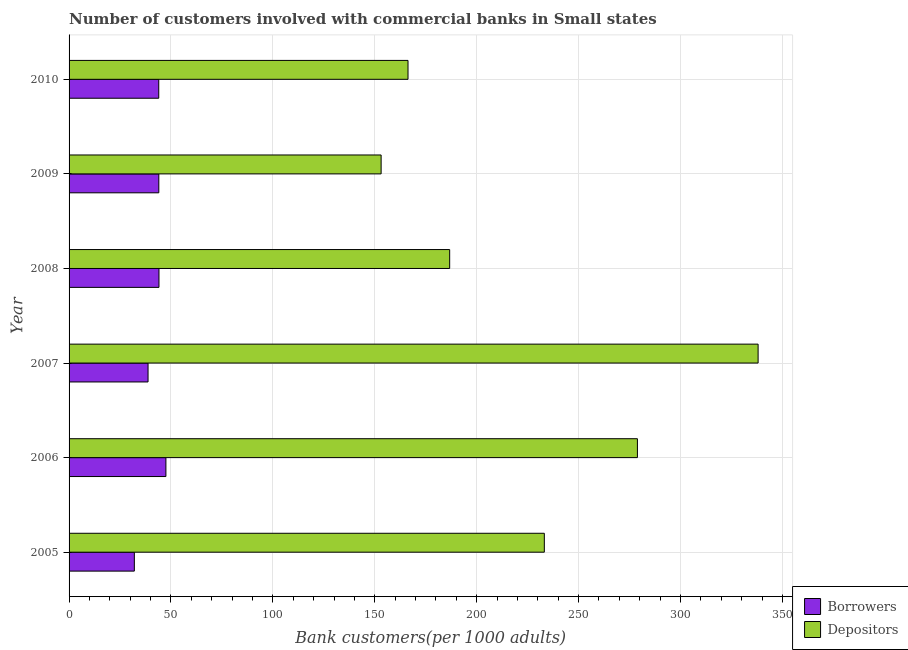How many different coloured bars are there?
Keep it short and to the point. 2. How many groups of bars are there?
Offer a very short reply. 6. How many bars are there on the 4th tick from the bottom?
Provide a succinct answer. 2. What is the number of borrowers in 2005?
Provide a succinct answer. 32.03. Across all years, what is the maximum number of depositors?
Offer a very short reply. 338.08. Across all years, what is the minimum number of depositors?
Make the answer very short. 153.11. In which year was the number of borrowers maximum?
Offer a very short reply. 2006. What is the total number of borrowers in the graph?
Your answer should be compact. 250.43. What is the difference between the number of borrowers in 2008 and that in 2009?
Give a very brief answer. 0.07. What is the difference between the number of depositors in 2005 and the number of borrowers in 2007?
Ensure brevity in your answer.  194.43. What is the average number of depositors per year?
Provide a succinct answer. 226.05. In the year 2005, what is the difference between the number of borrowers and number of depositors?
Your answer should be compact. -201.16. In how many years, is the number of depositors greater than 20 ?
Make the answer very short. 6. What is the ratio of the number of borrowers in 2006 to that in 2008?
Offer a terse response. 1.08. Is the number of depositors in 2006 less than that in 2009?
Make the answer very short. No. What is the difference between the highest and the second highest number of depositors?
Offer a terse response. 59.21. What is the difference between the highest and the lowest number of borrowers?
Offer a very short reply. 15.48. What does the 2nd bar from the top in 2007 represents?
Provide a succinct answer. Borrowers. What does the 2nd bar from the bottom in 2007 represents?
Give a very brief answer. Depositors. How many bars are there?
Give a very brief answer. 12. Are all the bars in the graph horizontal?
Your answer should be very brief. Yes. How many years are there in the graph?
Your response must be concise. 6. What is the difference between two consecutive major ticks on the X-axis?
Your answer should be compact. 50. Does the graph contain any zero values?
Ensure brevity in your answer.  No. Does the graph contain grids?
Your response must be concise. Yes. Where does the legend appear in the graph?
Provide a succinct answer. Bottom right. What is the title of the graph?
Offer a terse response. Number of customers involved with commercial banks in Small states. Does "Under five" appear as one of the legend labels in the graph?
Your answer should be compact. No. What is the label or title of the X-axis?
Provide a short and direct response. Bank customers(per 1000 adults). What is the label or title of the Y-axis?
Offer a very short reply. Year. What is the Bank customers(per 1000 adults) in Borrowers in 2005?
Your response must be concise. 32.03. What is the Bank customers(per 1000 adults) in Depositors in 2005?
Give a very brief answer. 233.18. What is the Bank customers(per 1000 adults) in Borrowers in 2006?
Offer a terse response. 47.51. What is the Bank customers(per 1000 adults) in Depositors in 2006?
Ensure brevity in your answer.  278.86. What is the Bank customers(per 1000 adults) in Borrowers in 2007?
Give a very brief answer. 38.75. What is the Bank customers(per 1000 adults) of Depositors in 2007?
Offer a very short reply. 338.08. What is the Bank customers(per 1000 adults) of Borrowers in 2008?
Keep it short and to the point. 44.11. What is the Bank customers(per 1000 adults) in Depositors in 2008?
Your response must be concise. 186.74. What is the Bank customers(per 1000 adults) of Borrowers in 2009?
Provide a succinct answer. 44.03. What is the Bank customers(per 1000 adults) of Depositors in 2009?
Your answer should be very brief. 153.11. What is the Bank customers(per 1000 adults) in Borrowers in 2010?
Provide a succinct answer. 44. What is the Bank customers(per 1000 adults) of Depositors in 2010?
Your answer should be compact. 166.31. Across all years, what is the maximum Bank customers(per 1000 adults) in Borrowers?
Keep it short and to the point. 47.51. Across all years, what is the maximum Bank customers(per 1000 adults) of Depositors?
Keep it short and to the point. 338.08. Across all years, what is the minimum Bank customers(per 1000 adults) of Borrowers?
Your response must be concise. 32.03. Across all years, what is the minimum Bank customers(per 1000 adults) in Depositors?
Keep it short and to the point. 153.11. What is the total Bank customers(per 1000 adults) in Borrowers in the graph?
Provide a succinct answer. 250.43. What is the total Bank customers(per 1000 adults) of Depositors in the graph?
Provide a succinct answer. 1356.28. What is the difference between the Bank customers(per 1000 adults) of Borrowers in 2005 and that in 2006?
Your answer should be very brief. -15.48. What is the difference between the Bank customers(per 1000 adults) of Depositors in 2005 and that in 2006?
Offer a terse response. -45.68. What is the difference between the Bank customers(per 1000 adults) of Borrowers in 2005 and that in 2007?
Your answer should be compact. -6.72. What is the difference between the Bank customers(per 1000 adults) in Depositors in 2005 and that in 2007?
Your response must be concise. -104.89. What is the difference between the Bank customers(per 1000 adults) in Borrowers in 2005 and that in 2008?
Ensure brevity in your answer.  -12.08. What is the difference between the Bank customers(per 1000 adults) in Depositors in 2005 and that in 2008?
Make the answer very short. 46.44. What is the difference between the Bank customers(per 1000 adults) of Borrowers in 2005 and that in 2009?
Offer a very short reply. -12. What is the difference between the Bank customers(per 1000 adults) of Depositors in 2005 and that in 2009?
Your answer should be compact. 80.08. What is the difference between the Bank customers(per 1000 adults) in Borrowers in 2005 and that in 2010?
Make the answer very short. -11.98. What is the difference between the Bank customers(per 1000 adults) of Depositors in 2005 and that in 2010?
Provide a succinct answer. 66.88. What is the difference between the Bank customers(per 1000 adults) of Borrowers in 2006 and that in 2007?
Provide a short and direct response. 8.76. What is the difference between the Bank customers(per 1000 adults) of Depositors in 2006 and that in 2007?
Your response must be concise. -59.21. What is the difference between the Bank customers(per 1000 adults) in Borrowers in 2006 and that in 2008?
Your answer should be compact. 3.4. What is the difference between the Bank customers(per 1000 adults) of Depositors in 2006 and that in 2008?
Provide a succinct answer. 92.12. What is the difference between the Bank customers(per 1000 adults) in Borrowers in 2006 and that in 2009?
Provide a succinct answer. 3.48. What is the difference between the Bank customers(per 1000 adults) of Depositors in 2006 and that in 2009?
Provide a short and direct response. 125.76. What is the difference between the Bank customers(per 1000 adults) of Borrowers in 2006 and that in 2010?
Your answer should be compact. 3.5. What is the difference between the Bank customers(per 1000 adults) in Depositors in 2006 and that in 2010?
Your answer should be compact. 112.56. What is the difference between the Bank customers(per 1000 adults) in Borrowers in 2007 and that in 2008?
Give a very brief answer. -5.36. What is the difference between the Bank customers(per 1000 adults) of Depositors in 2007 and that in 2008?
Your answer should be compact. 151.33. What is the difference between the Bank customers(per 1000 adults) of Borrowers in 2007 and that in 2009?
Your answer should be compact. -5.28. What is the difference between the Bank customers(per 1000 adults) of Depositors in 2007 and that in 2009?
Provide a short and direct response. 184.97. What is the difference between the Bank customers(per 1000 adults) in Borrowers in 2007 and that in 2010?
Your response must be concise. -5.25. What is the difference between the Bank customers(per 1000 adults) of Depositors in 2007 and that in 2010?
Give a very brief answer. 171.77. What is the difference between the Bank customers(per 1000 adults) in Borrowers in 2008 and that in 2009?
Provide a short and direct response. 0.08. What is the difference between the Bank customers(per 1000 adults) of Depositors in 2008 and that in 2009?
Offer a very short reply. 33.63. What is the difference between the Bank customers(per 1000 adults) in Borrowers in 2008 and that in 2010?
Give a very brief answer. 0.1. What is the difference between the Bank customers(per 1000 adults) in Depositors in 2008 and that in 2010?
Your response must be concise. 20.43. What is the difference between the Bank customers(per 1000 adults) in Borrowers in 2009 and that in 2010?
Your answer should be very brief. 0.03. What is the difference between the Bank customers(per 1000 adults) in Depositors in 2009 and that in 2010?
Make the answer very short. -13.2. What is the difference between the Bank customers(per 1000 adults) in Borrowers in 2005 and the Bank customers(per 1000 adults) in Depositors in 2006?
Offer a very short reply. -246.84. What is the difference between the Bank customers(per 1000 adults) in Borrowers in 2005 and the Bank customers(per 1000 adults) in Depositors in 2007?
Your response must be concise. -306.05. What is the difference between the Bank customers(per 1000 adults) in Borrowers in 2005 and the Bank customers(per 1000 adults) in Depositors in 2008?
Your response must be concise. -154.71. What is the difference between the Bank customers(per 1000 adults) in Borrowers in 2005 and the Bank customers(per 1000 adults) in Depositors in 2009?
Provide a short and direct response. -121.08. What is the difference between the Bank customers(per 1000 adults) in Borrowers in 2005 and the Bank customers(per 1000 adults) in Depositors in 2010?
Your response must be concise. -134.28. What is the difference between the Bank customers(per 1000 adults) in Borrowers in 2006 and the Bank customers(per 1000 adults) in Depositors in 2007?
Keep it short and to the point. -290.57. What is the difference between the Bank customers(per 1000 adults) of Borrowers in 2006 and the Bank customers(per 1000 adults) of Depositors in 2008?
Make the answer very short. -139.23. What is the difference between the Bank customers(per 1000 adults) of Borrowers in 2006 and the Bank customers(per 1000 adults) of Depositors in 2009?
Your response must be concise. -105.6. What is the difference between the Bank customers(per 1000 adults) of Borrowers in 2006 and the Bank customers(per 1000 adults) of Depositors in 2010?
Make the answer very short. -118.8. What is the difference between the Bank customers(per 1000 adults) of Borrowers in 2007 and the Bank customers(per 1000 adults) of Depositors in 2008?
Offer a terse response. -147.99. What is the difference between the Bank customers(per 1000 adults) in Borrowers in 2007 and the Bank customers(per 1000 adults) in Depositors in 2009?
Provide a succinct answer. -114.36. What is the difference between the Bank customers(per 1000 adults) in Borrowers in 2007 and the Bank customers(per 1000 adults) in Depositors in 2010?
Your answer should be very brief. -127.56. What is the difference between the Bank customers(per 1000 adults) of Borrowers in 2008 and the Bank customers(per 1000 adults) of Depositors in 2009?
Keep it short and to the point. -109. What is the difference between the Bank customers(per 1000 adults) in Borrowers in 2008 and the Bank customers(per 1000 adults) in Depositors in 2010?
Keep it short and to the point. -122.2. What is the difference between the Bank customers(per 1000 adults) of Borrowers in 2009 and the Bank customers(per 1000 adults) of Depositors in 2010?
Make the answer very short. -122.28. What is the average Bank customers(per 1000 adults) of Borrowers per year?
Keep it short and to the point. 41.74. What is the average Bank customers(per 1000 adults) of Depositors per year?
Keep it short and to the point. 226.05. In the year 2005, what is the difference between the Bank customers(per 1000 adults) of Borrowers and Bank customers(per 1000 adults) of Depositors?
Keep it short and to the point. -201.15. In the year 2006, what is the difference between the Bank customers(per 1000 adults) in Borrowers and Bank customers(per 1000 adults) in Depositors?
Your response must be concise. -231.35. In the year 2007, what is the difference between the Bank customers(per 1000 adults) in Borrowers and Bank customers(per 1000 adults) in Depositors?
Make the answer very short. -299.33. In the year 2008, what is the difference between the Bank customers(per 1000 adults) in Borrowers and Bank customers(per 1000 adults) in Depositors?
Offer a terse response. -142.64. In the year 2009, what is the difference between the Bank customers(per 1000 adults) of Borrowers and Bank customers(per 1000 adults) of Depositors?
Provide a succinct answer. -109.08. In the year 2010, what is the difference between the Bank customers(per 1000 adults) in Borrowers and Bank customers(per 1000 adults) in Depositors?
Give a very brief answer. -122.3. What is the ratio of the Bank customers(per 1000 adults) in Borrowers in 2005 to that in 2006?
Your answer should be very brief. 0.67. What is the ratio of the Bank customers(per 1000 adults) in Depositors in 2005 to that in 2006?
Give a very brief answer. 0.84. What is the ratio of the Bank customers(per 1000 adults) in Borrowers in 2005 to that in 2007?
Make the answer very short. 0.83. What is the ratio of the Bank customers(per 1000 adults) of Depositors in 2005 to that in 2007?
Your answer should be compact. 0.69. What is the ratio of the Bank customers(per 1000 adults) of Borrowers in 2005 to that in 2008?
Offer a terse response. 0.73. What is the ratio of the Bank customers(per 1000 adults) of Depositors in 2005 to that in 2008?
Your answer should be compact. 1.25. What is the ratio of the Bank customers(per 1000 adults) in Borrowers in 2005 to that in 2009?
Ensure brevity in your answer.  0.73. What is the ratio of the Bank customers(per 1000 adults) of Depositors in 2005 to that in 2009?
Your response must be concise. 1.52. What is the ratio of the Bank customers(per 1000 adults) in Borrowers in 2005 to that in 2010?
Keep it short and to the point. 0.73. What is the ratio of the Bank customers(per 1000 adults) in Depositors in 2005 to that in 2010?
Make the answer very short. 1.4. What is the ratio of the Bank customers(per 1000 adults) in Borrowers in 2006 to that in 2007?
Give a very brief answer. 1.23. What is the ratio of the Bank customers(per 1000 adults) of Depositors in 2006 to that in 2007?
Keep it short and to the point. 0.82. What is the ratio of the Bank customers(per 1000 adults) of Borrowers in 2006 to that in 2008?
Make the answer very short. 1.08. What is the ratio of the Bank customers(per 1000 adults) of Depositors in 2006 to that in 2008?
Keep it short and to the point. 1.49. What is the ratio of the Bank customers(per 1000 adults) in Borrowers in 2006 to that in 2009?
Provide a short and direct response. 1.08. What is the ratio of the Bank customers(per 1000 adults) of Depositors in 2006 to that in 2009?
Provide a short and direct response. 1.82. What is the ratio of the Bank customers(per 1000 adults) in Borrowers in 2006 to that in 2010?
Your answer should be very brief. 1.08. What is the ratio of the Bank customers(per 1000 adults) in Depositors in 2006 to that in 2010?
Make the answer very short. 1.68. What is the ratio of the Bank customers(per 1000 adults) in Borrowers in 2007 to that in 2008?
Provide a succinct answer. 0.88. What is the ratio of the Bank customers(per 1000 adults) of Depositors in 2007 to that in 2008?
Provide a short and direct response. 1.81. What is the ratio of the Bank customers(per 1000 adults) of Borrowers in 2007 to that in 2009?
Ensure brevity in your answer.  0.88. What is the ratio of the Bank customers(per 1000 adults) in Depositors in 2007 to that in 2009?
Offer a terse response. 2.21. What is the ratio of the Bank customers(per 1000 adults) in Borrowers in 2007 to that in 2010?
Give a very brief answer. 0.88. What is the ratio of the Bank customers(per 1000 adults) of Depositors in 2007 to that in 2010?
Offer a very short reply. 2.03. What is the ratio of the Bank customers(per 1000 adults) of Borrowers in 2008 to that in 2009?
Ensure brevity in your answer.  1. What is the ratio of the Bank customers(per 1000 adults) in Depositors in 2008 to that in 2009?
Your response must be concise. 1.22. What is the ratio of the Bank customers(per 1000 adults) of Depositors in 2008 to that in 2010?
Your response must be concise. 1.12. What is the ratio of the Bank customers(per 1000 adults) in Borrowers in 2009 to that in 2010?
Your answer should be compact. 1. What is the ratio of the Bank customers(per 1000 adults) of Depositors in 2009 to that in 2010?
Your answer should be very brief. 0.92. What is the difference between the highest and the second highest Bank customers(per 1000 adults) in Borrowers?
Your answer should be compact. 3.4. What is the difference between the highest and the second highest Bank customers(per 1000 adults) of Depositors?
Keep it short and to the point. 59.21. What is the difference between the highest and the lowest Bank customers(per 1000 adults) of Borrowers?
Offer a terse response. 15.48. What is the difference between the highest and the lowest Bank customers(per 1000 adults) in Depositors?
Ensure brevity in your answer.  184.97. 